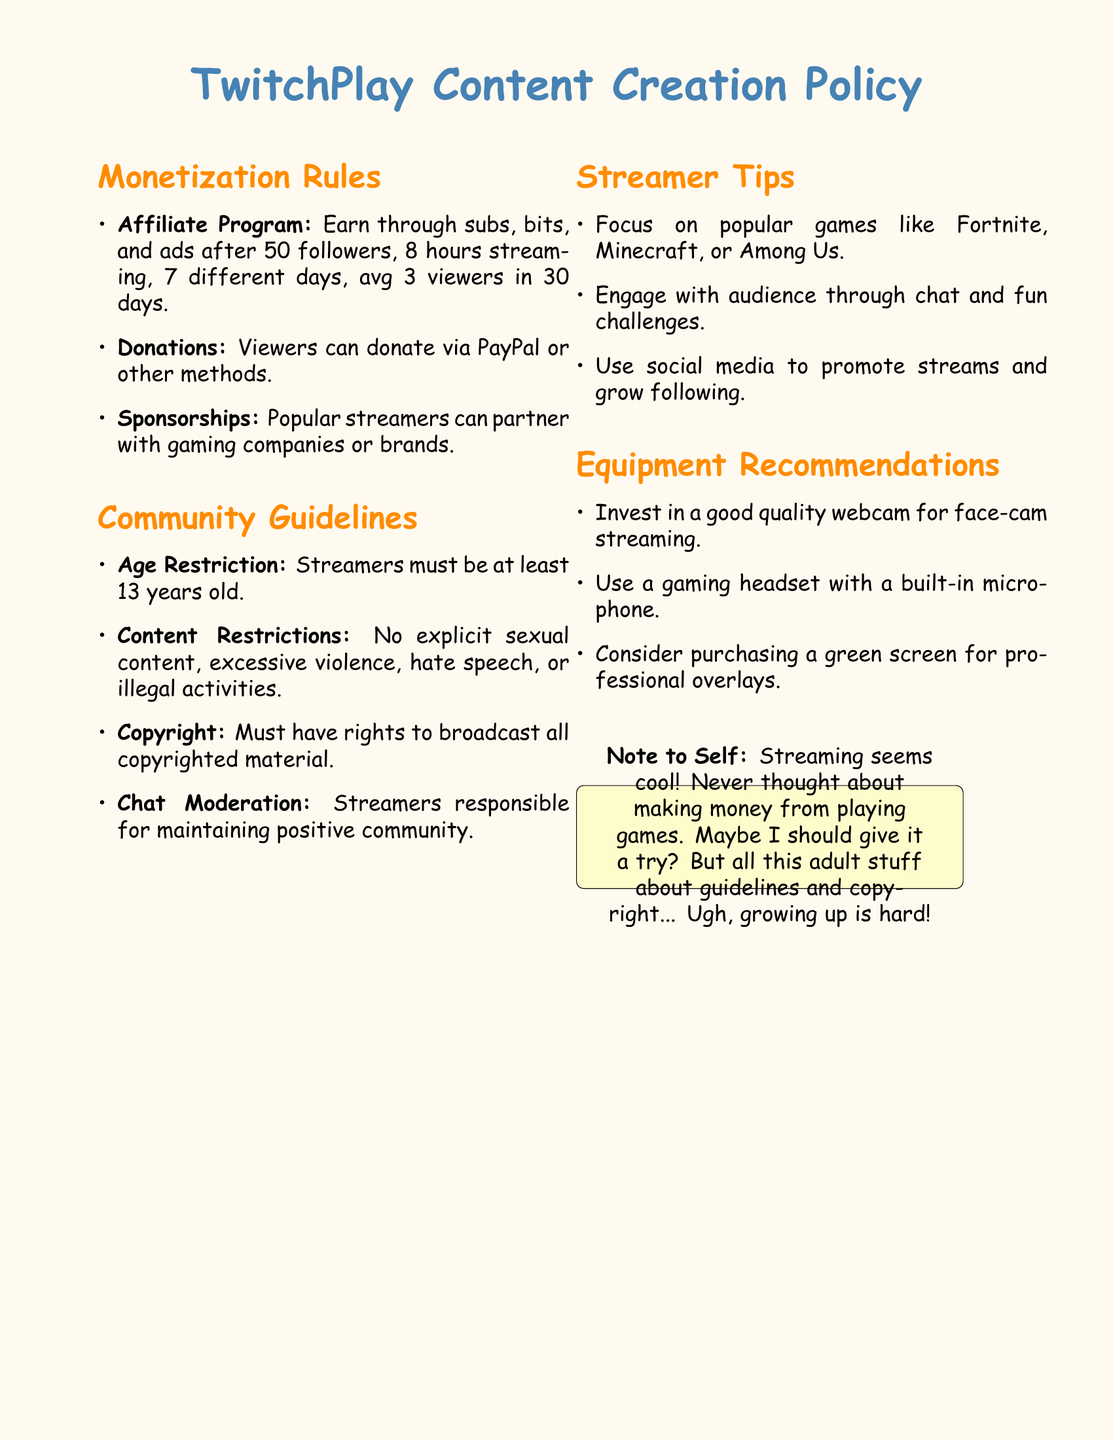What is the minimum age requirement to be a streamer? The document states that streamers must be at least 13 years old to participate.
Answer: 13 years old How many hours must a streamer have streamed to qualify for the Affiliate Program? According to the policy, a streamer must have streamed for at least 8 hours.
Answer: 8 hours What is the primary method for viewers to donate to streamers? The document mentions donations can be made via PayPal or other methods, identifying PayPal as a primary method.
Answer: PayPal Which popular games are recommended for streamers to focus on? The document lists popular games to focus on, including Fortnite, Minecraft, and Among Us.
Answer: Fortnite, Minecraft, Among Us What content is strictly prohibited by the Community Guidelines? The document specifies that explicit sexual content, excessive violence, hate speech, or illegal activities are not allowed.
Answer: Explicit sexual content, excessive violence, hate speech, illegal activities What is expected of streamers regarding chat moderation? The policy indicates that streamers are responsible for maintaining a positive community in their chat.
Answer: Maintaining positive community What should streamers invest in for better streaming quality? The document provides guidance to invest in good quality webcams, gaming headsets, and possibly green screens for overlays.
Answer: Good quality webcam What type of partnerships can popular streamers pursue? The document states that popular streamers can partner with gaming companies or brands for sponsorships.
Answer: Gaming companies or brands What is a suggested method to promote streams? The document suggests using social media platforms to help promote streams and grow an audience.
Answer: Social media 